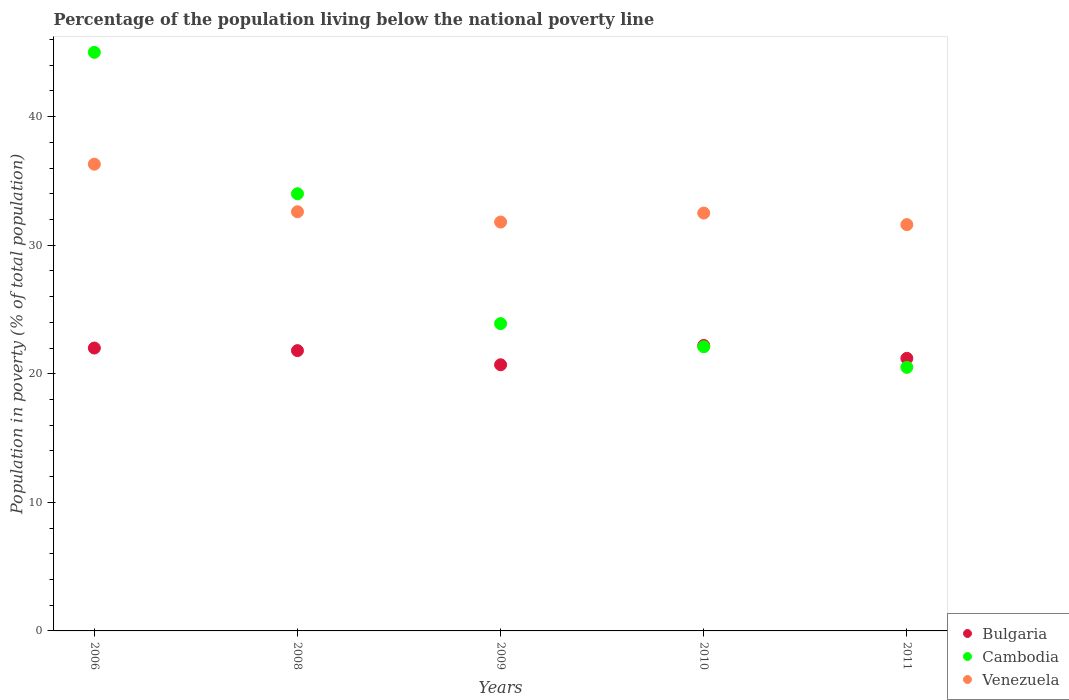What is the percentage of the population living below the national poverty line in Cambodia in 2008?
Keep it short and to the point. 34. Across all years, what is the maximum percentage of the population living below the national poverty line in Bulgaria?
Keep it short and to the point. 22.2. In which year was the percentage of the population living below the national poverty line in Bulgaria minimum?
Keep it short and to the point. 2009. What is the total percentage of the population living below the national poverty line in Bulgaria in the graph?
Ensure brevity in your answer.  107.9. What is the difference between the percentage of the population living below the national poverty line in Cambodia in 2006 and that in 2011?
Your answer should be compact. 24.5. What is the difference between the percentage of the population living below the national poverty line in Venezuela in 2011 and the percentage of the population living below the national poverty line in Cambodia in 2009?
Ensure brevity in your answer.  7.7. What is the average percentage of the population living below the national poverty line in Cambodia per year?
Give a very brief answer. 29.1. In the year 2006, what is the difference between the percentage of the population living below the national poverty line in Venezuela and percentage of the population living below the national poverty line in Cambodia?
Offer a terse response. -8.7. In how many years, is the percentage of the population living below the national poverty line in Cambodia greater than 26 %?
Make the answer very short. 2. What is the ratio of the percentage of the population living below the national poverty line in Bulgaria in 2009 to that in 2010?
Keep it short and to the point. 0.93. Is the difference between the percentage of the population living below the national poverty line in Venezuela in 2006 and 2010 greater than the difference between the percentage of the population living below the national poverty line in Cambodia in 2006 and 2010?
Provide a short and direct response. No. What is the difference between the highest and the lowest percentage of the population living below the national poverty line in Bulgaria?
Make the answer very short. 1.5. Is it the case that in every year, the sum of the percentage of the population living below the national poverty line in Bulgaria and percentage of the population living below the national poverty line in Cambodia  is greater than the percentage of the population living below the national poverty line in Venezuela?
Provide a short and direct response. Yes. Does the percentage of the population living below the national poverty line in Bulgaria monotonically increase over the years?
Give a very brief answer. No. Is the percentage of the population living below the national poverty line in Bulgaria strictly greater than the percentage of the population living below the national poverty line in Venezuela over the years?
Ensure brevity in your answer.  No. How many dotlines are there?
Make the answer very short. 3. How many years are there in the graph?
Offer a terse response. 5. What is the difference between two consecutive major ticks on the Y-axis?
Keep it short and to the point. 10. Where does the legend appear in the graph?
Your answer should be very brief. Bottom right. How many legend labels are there?
Your answer should be very brief. 3. What is the title of the graph?
Make the answer very short. Percentage of the population living below the national poverty line. Does "Sub-Saharan Africa (all income levels)" appear as one of the legend labels in the graph?
Provide a succinct answer. No. What is the label or title of the X-axis?
Provide a succinct answer. Years. What is the label or title of the Y-axis?
Your answer should be compact. Population in poverty (% of total population). What is the Population in poverty (% of total population) of Cambodia in 2006?
Make the answer very short. 45. What is the Population in poverty (% of total population) of Venezuela in 2006?
Ensure brevity in your answer.  36.3. What is the Population in poverty (% of total population) in Bulgaria in 2008?
Keep it short and to the point. 21.8. What is the Population in poverty (% of total population) of Cambodia in 2008?
Your answer should be very brief. 34. What is the Population in poverty (% of total population) of Venezuela in 2008?
Keep it short and to the point. 32.6. What is the Population in poverty (% of total population) in Bulgaria in 2009?
Provide a short and direct response. 20.7. What is the Population in poverty (% of total population) in Cambodia in 2009?
Offer a very short reply. 23.9. What is the Population in poverty (% of total population) of Venezuela in 2009?
Give a very brief answer. 31.8. What is the Population in poverty (% of total population) in Cambodia in 2010?
Provide a succinct answer. 22.1. What is the Population in poverty (% of total population) of Venezuela in 2010?
Give a very brief answer. 32.5. What is the Population in poverty (% of total population) of Bulgaria in 2011?
Your answer should be compact. 21.2. What is the Population in poverty (% of total population) of Cambodia in 2011?
Offer a terse response. 20.5. What is the Population in poverty (% of total population) of Venezuela in 2011?
Ensure brevity in your answer.  31.6. Across all years, what is the maximum Population in poverty (% of total population) in Bulgaria?
Your response must be concise. 22.2. Across all years, what is the maximum Population in poverty (% of total population) of Venezuela?
Keep it short and to the point. 36.3. Across all years, what is the minimum Population in poverty (% of total population) in Bulgaria?
Ensure brevity in your answer.  20.7. Across all years, what is the minimum Population in poverty (% of total population) of Cambodia?
Keep it short and to the point. 20.5. Across all years, what is the minimum Population in poverty (% of total population) of Venezuela?
Offer a very short reply. 31.6. What is the total Population in poverty (% of total population) in Bulgaria in the graph?
Make the answer very short. 107.9. What is the total Population in poverty (% of total population) of Cambodia in the graph?
Offer a terse response. 145.5. What is the total Population in poverty (% of total population) in Venezuela in the graph?
Offer a very short reply. 164.8. What is the difference between the Population in poverty (% of total population) in Bulgaria in 2006 and that in 2008?
Give a very brief answer. 0.2. What is the difference between the Population in poverty (% of total population) in Venezuela in 2006 and that in 2008?
Offer a terse response. 3.7. What is the difference between the Population in poverty (% of total population) in Cambodia in 2006 and that in 2009?
Provide a short and direct response. 21.1. What is the difference between the Population in poverty (% of total population) in Cambodia in 2006 and that in 2010?
Provide a succinct answer. 22.9. What is the difference between the Population in poverty (% of total population) of Venezuela in 2006 and that in 2010?
Offer a terse response. 3.8. What is the difference between the Population in poverty (% of total population) of Bulgaria in 2006 and that in 2011?
Provide a succinct answer. 0.8. What is the difference between the Population in poverty (% of total population) of Venezuela in 2006 and that in 2011?
Your answer should be compact. 4.7. What is the difference between the Population in poverty (% of total population) of Bulgaria in 2008 and that in 2009?
Your response must be concise. 1.1. What is the difference between the Population in poverty (% of total population) of Cambodia in 2008 and that in 2009?
Ensure brevity in your answer.  10.1. What is the difference between the Population in poverty (% of total population) in Venezuela in 2008 and that in 2010?
Your response must be concise. 0.1. What is the difference between the Population in poverty (% of total population) in Bulgaria in 2009 and that in 2010?
Offer a terse response. -1.5. What is the difference between the Population in poverty (% of total population) in Cambodia in 2009 and that in 2010?
Keep it short and to the point. 1.8. What is the difference between the Population in poverty (% of total population) of Venezuela in 2009 and that in 2010?
Give a very brief answer. -0.7. What is the difference between the Population in poverty (% of total population) in Cambodia in 2009 and that in 2011?
Provide a short and direct response. 3.4. What is the difference between the Population in poverty (% of total population) of Venezuela in 2009 and that in 2011?
Your answer should be very brief. 0.2. What is the difference between the Population in poverty (% of total population) of Bulgaria in 2010 and that in 2011?
Keep it short and to the point. 1. What is the difference between the Population in poverty (% of total population) in Cambodia in 2010 and that in 2011?
Make the answer very short. 1.6. What is the difference between the Population in poverty (% of total population) of Venezuela in 2010 and that in 2011?
Your answer should be very brief. 0.9. What is the difference between the Population in poverty (% of total population) in Bulgaria in 2006 and the Population in poverty (% of total population) in Cambodia in 2008?
Your answer should be compact. -12. What is the difference between the Population in poverty (% of total population) of Cambodia in 2006 and the Population in poverty (% of total population) of Venezuela in 2008?
Provide a succinct answer. 12.4. What is the difference between the Population in poverty (% of total population) in Cambodia in 2006 and the Population in poverty (% of total population) in Venezuela in 2009?
Your answer should be compact. 13.2. What is the difference between the Population in poverty (% of total population) in Bulgaria in 2006 and the Population in poverty (% of total population) in Venezuela in 2010?
Give a very brief answer. -10.5. What is the difference between the Population in poverty (% of total population) of Cambodia in 2006 and the Population in poverty (% of total population) of Venezuela in 2010?
Give a very brief answer. 12.5. What is the difference between the Population in poverty (% of total population) of Bulgaria in 2006 and the Population in poverty (% of total population) of Cambodia in 2011?
Your response must be concise. 1.5. What is the difference between the Population in poverty (% of total population) of Bulgaria in 2006 and the Population in poverty (% of total population) of Venezuela in 2011?
Offer a very short reply. -9.6. What is the difference between the Population in poverty (% of total population) of Cambodia in 2006 and the Population in poverty (% of total population) of Venezuela in 2011?
Make the answer very short. 13.4. What is the difference between the Population in poverty (% of total population) in Cambodia in 2008 and the Population in poverty (% of total population) in Venezuela in 2009?
Your answer should be compact. 2.2. What is the difference between the Population in poverty (% of total population) in Bulgaria in 2008 and the Population in poverty (% of total population) in Venezuela in 2010?
Your answer should be very brief. -10.7. What is the difference between the Population in poverty (% of total population) in Bulgaria in 2008 and the Population in poverty (% of total population) in Cambodia in 2011?
Offer a terse response. 1.3. What is the difference between the Population in poverty (% of total population) in Bulgaria in 2009 and the Population in poverty (% of total population) in Venezuela in 2010?
Keep it short and to the point. -11.8. What is the difference between the Population in poverty (% of total population) of Cambodia in 2009 and the Population in poverty (% of total population) of Venezuela in 2010?
Your answer should be very brief. -8.6. What is the difference between the Population in poverty (% of total population) of Bulgaria in 2009 and the Population in poverty (% of total population) of Cambodia in 2011?
Keep it short and to the point. 0.2. What is the difference between the Population in poverty (% of total population) of Cambodia in 2009 and the Population in poverty (% of total population) of Venezuela in 2011?
Your response must be concise. -7.7. What is the difference between the Population in poverty (% of total population) of Bulgaria in 2010 and the Population in poverty (% of total population) of Cambodia in 2011?
Your answer should be very brief. 1.7. What is the average Population in poverty (% of total population) of Bulgaria per year?
Your response must be concise. 21.58. What is the average Population in poverty (% of total population) in Cambodia per year?
Your answer should be compact. 29.1. What is the average Population in poverty (% of total population) of Venezuela per year?
Give a very brief answer. 32.96. In the year 2006, what is the difference between the Population in poverty (% of total population) in Bulgaria and Population in poverty (% of total population) in Venezuela?
Provide a short and direct response. -14.3. In the year 2006, what is the difference between the Population in poverty (% of total population) in Cambodia and Population in poverty (% of total population) in Venezuela?
Give a very brief answer. 8.7. In the year 2008, what is the difference between the Population in poverty (% of total population) in Bulgaria and Population in poverty (% of total population) in Cambodia?
Your answer should be compact. -12.2. In the year 2009, what is the difference between the Population in poverty (% of total population) in Bulgaria and Population in poverty (% of total population) in Cambodia?
Make the answer very short. -3.2. In the year 2009, what is the difference between the Population in poverty (% of total population) in Bulgaria and Population in poverty (% of total population) in Venezuela?
Keep it short and to the point. -11.1. In the year 2009, what is the difference between the Population in poverty (% of total population) in Cambodia and Population in poverty (% of total population) in Venezuela?
Your answer should be compact. -7.9. In the year 2010, what is the difference between the Population in poverty (% of total population) in Bulgaria and Population in poverty (% of total population) in Cambodia?
Your answer should be very brief. 0.1. In the year 2010, what is the difference between the Population in poverty (% of total population) of Bulgaria and Population in poverty (% of total population) of Venezuela?
Your answer should be compact. -10.3. In the year 2010, what is the difference between the Population in poverty (% of total population) in Cambodia and Population in poverty (% of total population) in Venezuela?
Provide a succinct answer. -10.4. In the year 2011, what is the difference between the Population in poverty (% of total population) in Bulgaria and Population in poverty (% of total population) in Cambodia?
Keep it short and to the point. 0.7. What is the ratio of the Population in poverty (% of total population) in Bulgaria in 2006 to that in 2008?
Give a very brief answer. 1.01. What is the ratio of the Population in poverty (% of total population) in Cambodia in 2006 to that in 2008?
Ensure brevity in your answer.  1.32. What is the ratio of the Population in poverty (% of total population) of Venezuela in 2006 to that in 2008?
Provide a succinct answer. 1.11. What is the ratio of the Population in poverty (% of total population) in Bulgaria in 2006 to that in 2009?
Provide a short and direct response. 1.06. What is the ratio of the Population in poverty (% of total population) in Cambodia in 2006 to that in 2009?
Offer a terse response. 1.88. What is the ratio of the Population in poverty (% of total population) in Venezuela in 2006 to that in 2009?
Offer a very short reply. 1.14. What is the ratio of the Population in poverty (% of total population) in Cambodia in 2006 to that in 2010?
Give a very brief answer. 2.04. What is the ratio of the Population in poverty (% of total population) in Venezuela in 2006 to that in 2010?
Make the answer very short. 1.12. What is the ratio of the Population in poverty (% of total population) of Bulgaria in 2006 to that in 2011?
Offer a terse response. 1.04. What is the ratio of the Population in poverty (% of total population) of Cambodia in 2006 to that in 2011?
Your answer should be compact. 2.2. What is the ratio of the Population in poverty (% of total population) in Venezuela in 2006 to that in 2011?
Your answer should be very brief. 1.15. What is the ratio of the Population in poverty (% of total population) in Bulgaria in 2008 to that in 2009?
Make the answer very short. 1.05. What is the ratio of the Population in poverty (% of total population) of Cambodia in 2008 to that in 2009?
Your answer should be compact. 1.42. What is the ratio of the Population in poverty (% of total population) of Venezuela in 2008 to that in 2009?
Your response must be concise. 1.03. What is the ratio of the Population in poverty (% of total population) in Cambodia in 2008 to that in 2010?
Make the answer very short. 1.54. What is the ratio of the Population in poverty (% of total population) of Venezuela in 2008 to that in 2010?
Offer a terse response. 1. What is the ratio of the Population in poverty (% of total population) of Bulgaria in 2008 to that in 2011?
Your response must be concise. 1.03. What is the ratio of the Population in poverty (% of total population) in Cambodia in 2008 to that in 2011?
Provide a succinct answer. 1.66. What is the ratio of the Population in poverty (% of total population) in Venezuela in 2008 to that in 2011?
Your answer should be very brief. 1.03. What is the ratio of the Population in poverty (% of total population) in Bulgaria in 2009 to that in 2010?
Your answer should be very brief. 0.93. What is the ratio of the Population in poverty (% of total population) of Cambodia in 2009 to that in 2010?
Offer a very short reply. 1.08. What is the ratio of the Population in poverty (% of total population) of Venezuela in 2009 to that in 2010?
Keep it short and to the point. 0.98. What is the ratio of the Population in poverty (% of total population) in Bulgaria in 2009 to that in 2011?
Provide a succinct answer. 0.98. What is the ratio of the Population in poverty (% of total population) in Cambodia in 2009 to that in 2011?
Keep it short and to the point. 1.17. What is the ratio of the Population in poverty (% of total population) of Venezuela in 2009 to that in 2011?
Offer a very short reply. 1.01. What is the ratio of the Population in poverty (% of total population) in Bulgaria in 2010 to that in 2011?
Provide a succinct answer. 1.05. What is the ratio of the Population in poverty (% of total population) of Cambodia in 2010 to that in 2011?
Your answer should be very brief. 1.08. What is the ratio of the Population in poverty (% of total population) in Venezuela in 2010 to that in 2011?
Give a very brief answer. 1.03. What is the difference between the highest and the second highest Population in poverty (% of total population) of Cambodia?
Offer a very short reply. 11. What is the difference between the highest and the second highest Population in poverty (% of total population) of Venezuela?
Your answer should be compact. 3.7. What is the difference between the highest and the lowest Population in poverty (% of total population) in Bulgaria?
Offer a very short reply. 1.5. 